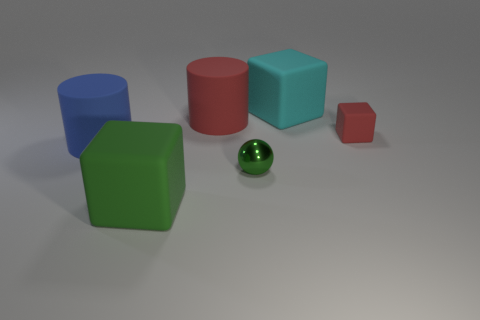Add 2 large blue rubber cylinders. How many objects exist? 8 Subtract all large matte blocks. How many blocks are left? 1 Subtract all cyan cubes. How many cubes are left? 2 Subtract 2 blocks. How many blocks are left? 1 Subtract 0 blue cubes. How many objects are left? 6 Subtract all cylinders. How many objects are left? 4 Subtract all yellow cylinders. Subtract all blue balls. How many cylinders are left? 2 Subtract all green balls. How many cyan cylinders are left? 0 Subtract all large purple rubber cylinders. Subtract all metal objects. How many objects are left? 5 Add 3 blue cylinders. How many blue cylinders are left? 4 